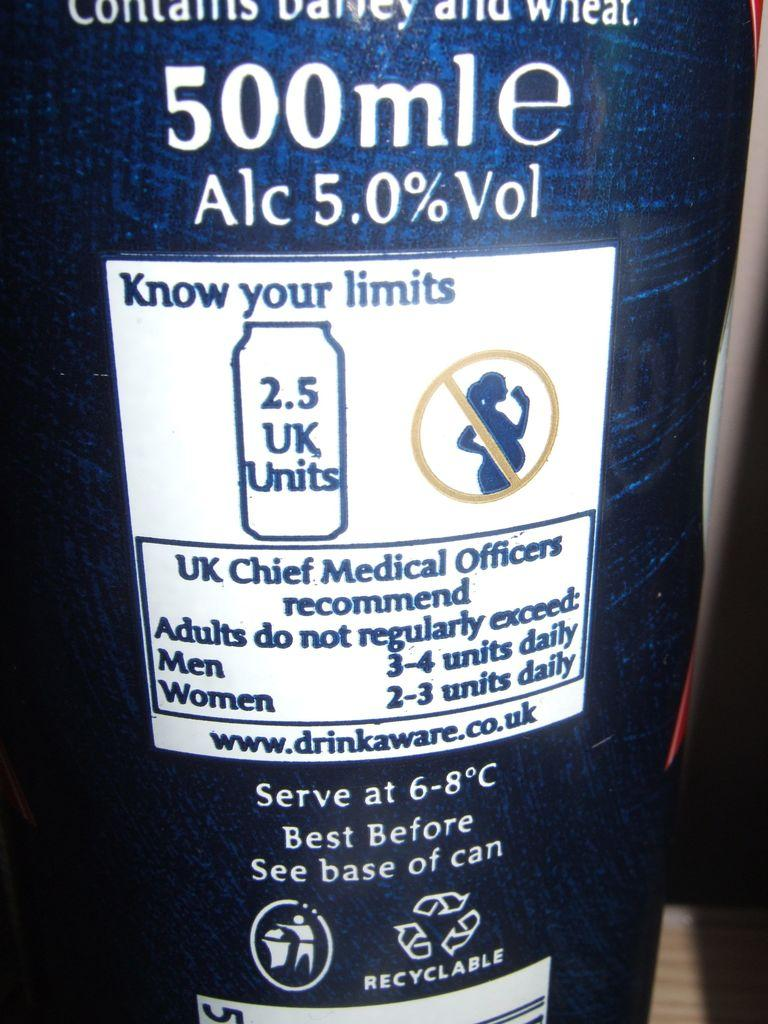<image>
Relay a brief, clear account of the picture shown. A 500ml bottle of beer that contains barley and wheat. 